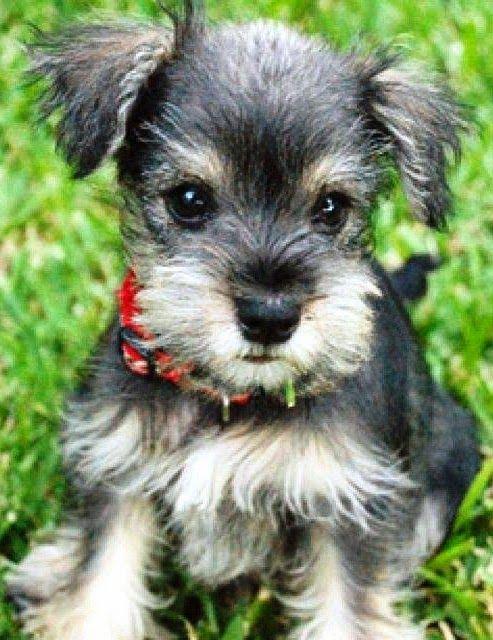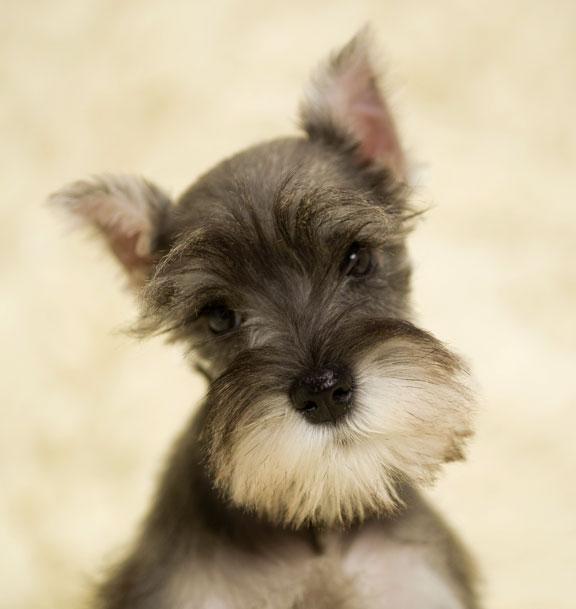The first image is the image on the left, the second image is the image on the right. Examine the images to the left and right. Is the description "There are exactly five puppies in one of the images." accurate? Answer yes or no. No. 